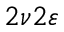Convert formula to latex. <formula><loc_0><loc_0><loc_500><loc_500>2 \nu 2 \varepsilon</formula> 